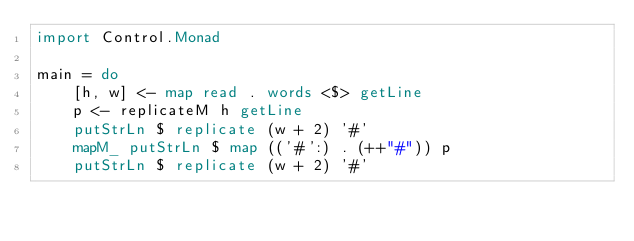Convert code to text. <code><loc_0><loc_0><loc_500><loc_500><_Haskell_>import Control.Monad

main = do
    [h, w] <- map read . words <$> getLine
    p <- replicateM h getLine
    putStrLn $ replicate (w + 2) '#'
    mapM_ putStrLn $ map (('#':) . (++"#")) p
    putStrLn $ replicate (w + 2) '#'</code> 